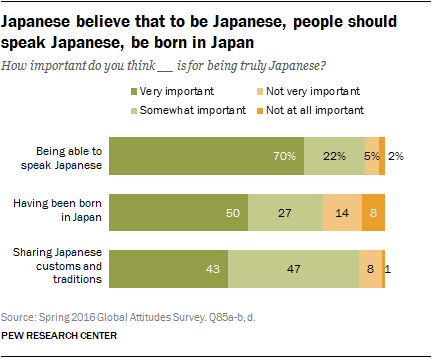Specify some key components in this picture. Dark green represents a very important aspect that should not be overlooked. Eight percent of respondents believe that being born in Japan is not at all important. 